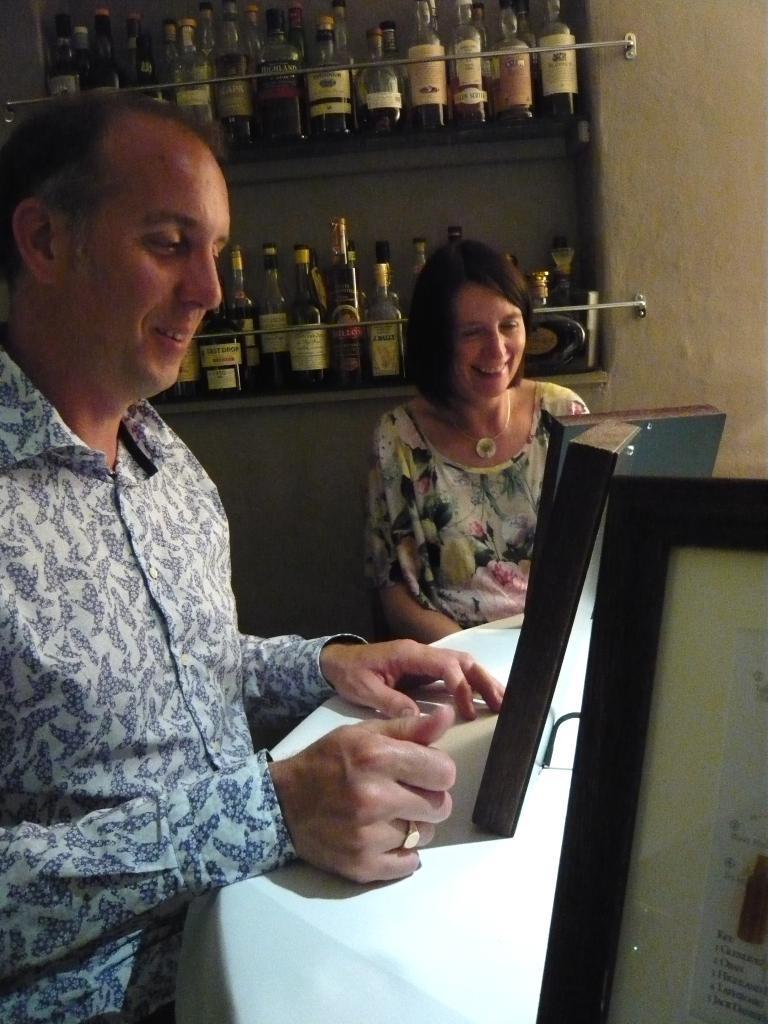Describe this image in one or two sentences. A man and woman are at the table looking at the frames. Behind them there are wine bottles. 